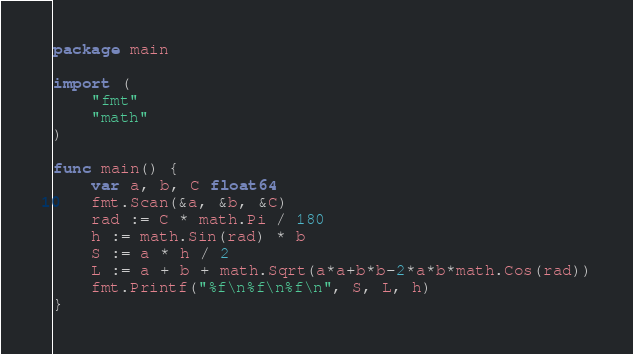<code> <loc_0><loc_0><loc_500><loc_500><_Go_>package main

import (
	"fmt"
	"math"
)

func main() {
	var a, b, C float64
	fmt.Scan(&a, &b, &C)
	rad := C * math.Pi / 180
	h := math.Sin(rad) * b
	S := a * h / 2
	L := a + b + math.Sqrt(a*a+b*b-2*a*b*math.Cos(rad))
	fmt.Printf("%f\n%f\n%f\n", S, L, h)
}

</code> 